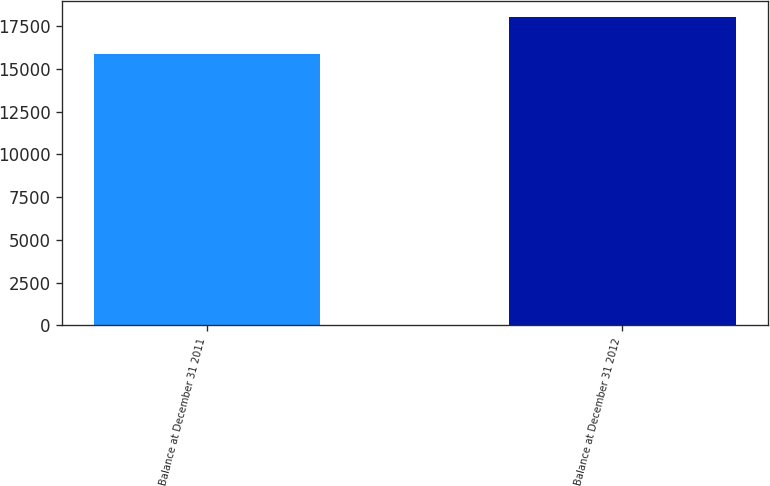Convert chart. <chart><loc_0><loc_0><loc_500><loc_500><bar_chart><fcel>Balance at December 31 2011<fcel>Balance at December 31 2012<nl><fcel>15862<fcel>18040<nl></chart> 